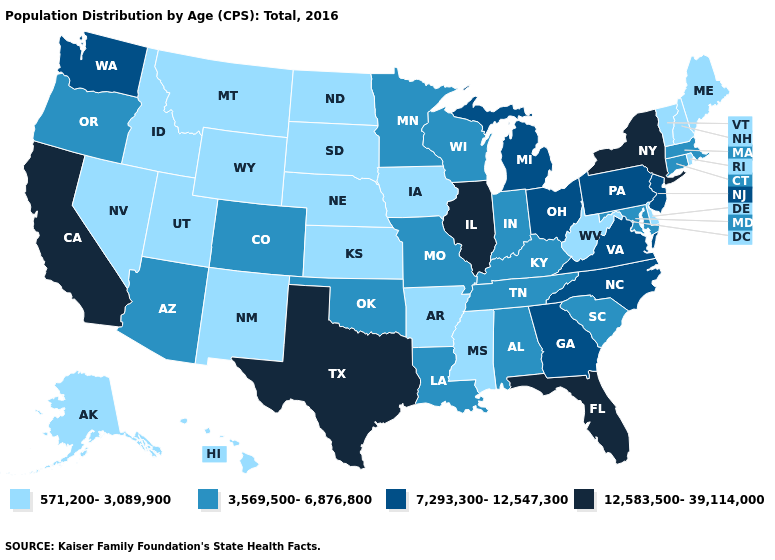Name the states that have a value in the range 7,293,300-12,547,300?
Give a very brief answer. Georgia, Michigan, New Jersey, North Carolina, Ohio, Pennsylvania, Virginia, Washington. Name the states that have a value in the range 12,583,500-39,114,000?
Give a very brief answer. California, Florida, Illinois, New York, Texas. Among the states that border Indiana , which have the lowest value?
Give a very brief answer. Kentucky. What is the highest value in the MidWest ?
Give a very brief answer. 12,583,500-39,114,000. What is the value of Montana?
Concise answer only. 571,200-3,089,900. Does Alaska have the lowest value in the USA?
Give a very brief answer. Yes. Does the first symbol in the legend represent the smallest category?
Concise answer only. Yes. What is the value of North Dakota?
Short answer required. 571,200-3,089,900. What is the value of Florida?
Write a very short answer. 12,583,500-39,114,000. Does Montana have a lower value than Alaska?
Give a very brief answer. No. Does the map have missing data?
Short answer required. No. Which states have the lowest value in the USA?
Keep it brief. Alaska, Arkansas, Delaware, Hawaii, Idaho, Iowa, Kansas, Maine, Mississippi, Montana, Nebraska, Nevada, New Hampshire, New Mexico, North Dakota, Rhode Island, South Dakota, Utah, Vermont, West Virginia, Wyoming. Which states have the lowest value in the MidWest?
Keep it brief. Iowa, Kansas, Nebraska, North Dakota, South Dakota. Name the states that have a value in the range 3,569,500-6,876,800?
Quick response, please. Alabama, Arizona, Colorado, Connecticut, Indiana, Kentucky, Louisiana, Maryland, Massachusetts, Minnesota, Missouri, Oklahoma, Oregon, South Carolina, Tennessee, Wisconsin. What is the value of Pennsylvania?
Keep it brief. 7,293,300-12,547,300. 